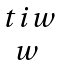<formula> <loc_0><loc_0><loc_500><loc_500>\begin{matrix} \ t i w \\ w \end{matrix}</formula> 